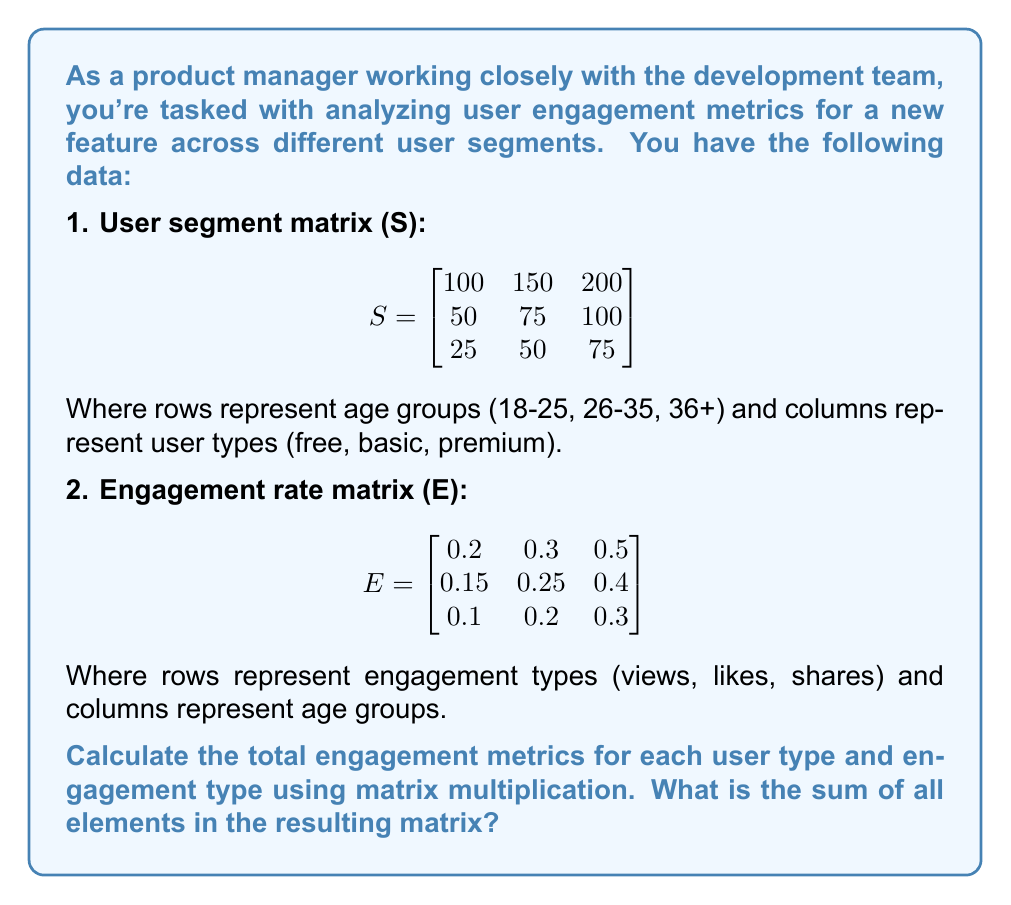Can you answer this question? To solve this problem, we need to follow these steps:

1. Multiply the User segment matrix (S) by the transpose of the Engagement rate matrix (E^T):

$$R = S \times E^T$$

2. Calculate the resulting matrix R:

$$R = \begin{bmatrix}
100 & 150 & 200 \\
50 & 75 & 100 \\
25 & 50 & 75
\end{bmatrix} \times 
\begin{bmatrix}
0.2 & 0.15 & 0.1 \\
0.3 & 0.25 & 0.2 \\
0.5 & 0.4 & 0.3
\end{bmatrix}$$

3. Perform the matrix multiplication:

$$R = \begin{bmatrix}
(100 \times 0.2 + 150 \times 0.3 + 200 \times 0.5) & (100 \times 0.15 + 150 \times 0.25 + 200 \times 0.4) & (100 \times 0.1 + 150 \times 0.2 + 200 \times 0.3) \\
(50 \times 0.2 + 75 \times 0.3 + 100 \times 0.5) & (50 \times 0.15 + 75 \times 0.25 + 100 \times 0.4) & (50 \times 0.1 + 75 \times 0.2 + 100 \times 0.3) \\
(25 \times 0.2 + 50 \times 0.3 + 75 \times 0.5) & (25 \times 0.15 + 50 \times 0.25 + 75 \times 0.4) & (25 \times 0.1 + 50 \times 0.2 + 75 \times 0.3)
\end{bmatrix}$$

4. Calculate the values:

$$R = \begin{bmatrix}
145 & 122.5 & 95 \\
72.5 & 61.25 & 47.5 \\
58.75 & 48.75 & 37.5
\end{bmatrix}$$

5. Sum all elements in the resulting matrix:

$145 + 122.5 + 95 + 72.5 + 61.25 + 47.5 + 58.75 + 48.75 + 37.5 = 688.75$
Answer: 688.75 